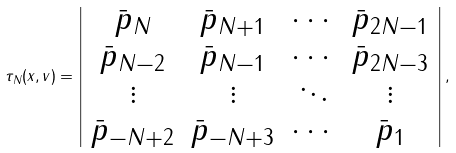Convert formula to latex. <formula><loc_0><loc_0><loc_500><loc_500>\tau _ { N } ( x , v ) = \left | \begin{array} { c c c c } \bar { p } _ { N } & \bar { p } _ { N + 1 } & \cdots & \bar { p } _ { 2 N - 1 } \\ \bar { p } _ { N - 2 } & \bar { p } _ { N - 1 } & \cdots & \bar { p } _ { 2 N - 3 } \\ \vdots & \vdots & \ddots & \vdots \\ \bar { p } _ { - N + 2 } & \bar { p } _ { - N + 3 } & \cdots & \bar { p } _ { 1 } \end{array} \right | ,</formula> 